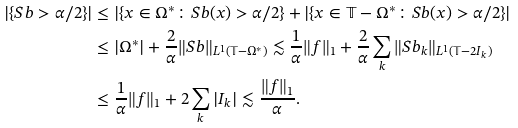Convert formula to latex. <formula><loc_0><loc_0><loc_500><loc_500>| \{ S b > \alpha / 2 \} | & \leq | \{ x \in \Omega ^ { * } \colon S b ( x ) > \alpha / 2 \} + | \{ x \in \mathbb { T } - \Omega ^ { * } \colon S b ( x ) > \alpha / 2 \} | \\ & \leq | \Omega ^ { * } | + \frac { 2 } { \alpha } \| S b \| _ { L ^ { 1 } ( \mathbb { T } - \Omega ^ { * } ) } \lesssim \frac { 1 } { \alpha } \| f \| _ { 1 } + \frac { 2 } { \alpha } \sum _ { k } \| S b _ { k } \| _ { L ^ { 1 } ( \mathbb { T } - 2 I _ { k } ) } \\ & \leq \frac { 1 } { \alpha } \| f \| _ { 1 } + 2 \sum _ { k } | I _ { k } | \lesssim \frac { \| f \| _ { 1 } } { \alpha } .</formula> 